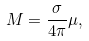<formula> <loc_0><loc_0><loc_500><loc_500>M = \frac { \sigma } { 4 \pi } \mu ,</formula> 